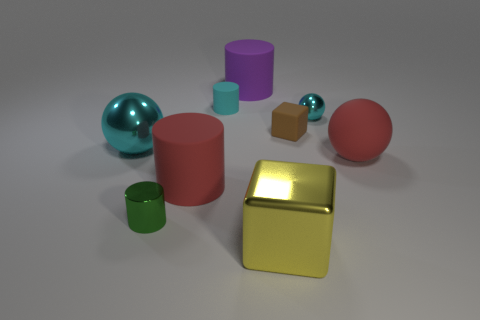What number of other objects are the same shape as the large yellow metal object?
Your answer should be very brief. 1. There is a red object on the right side of the big yellow metal thing; what shape is it?
Provide a succinct answer. Sphere. Are there any tiny metallic objects behind the red thing right of the large purple rubber cylinder?
Offer a very short reply. Yes. There is a big thing that is behind the big metallic cube and right of the big purple rubber thing; what is its color?
Your answer should be compact. Red. Are there any small metallic things that are in front of the large metal thing right of the cyan shiny sphere to the left of the small shiny cylinder?
Your response must be concise. No. What is the size of the other object that is the same shape as the big yellow thing?
Keep it short and to the point. Small. Are there any other things that are the same material as the yellow thing?
Ensure brevity in your answer.  Yes. Are there any blocks?
Ensure brevity in your answer.  Yes. There is a big cube; is its color the same as the small metal thing that is on the right side of the purple cylinder?
Make the answer very short. No. What is the size of the rubber cylinder that is in front of the red thing on the right side of the shiny ball to the right of the green shiny thing?
Give a very brief answer. Large. 